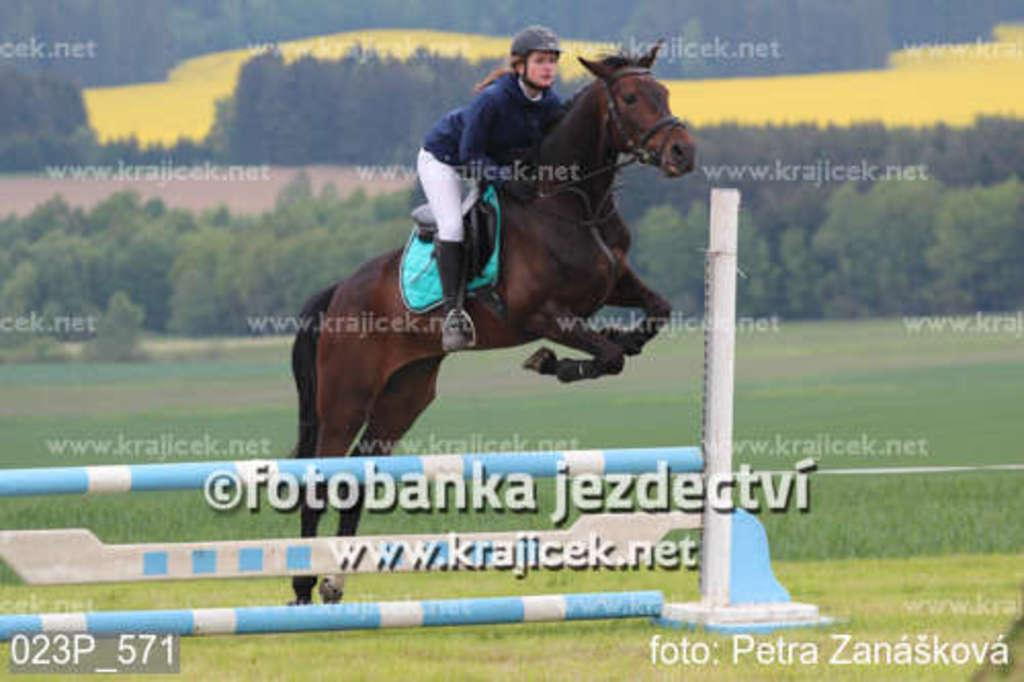What is the main subject in the foreground of the picture? There is a woman in the foreground of the picture. What is the woman doing in the picture? The woman is riding a horse. What action is the horse performing in the picture? The horse is jumping from a pole. What can be seen in the background of the picture? There are trees and grass visible in the background of the picture. What type of line can be seen crossing the stream in the image? There is no line or stream present in the image; it features a woman riding a horse that is jumping from a pole. 